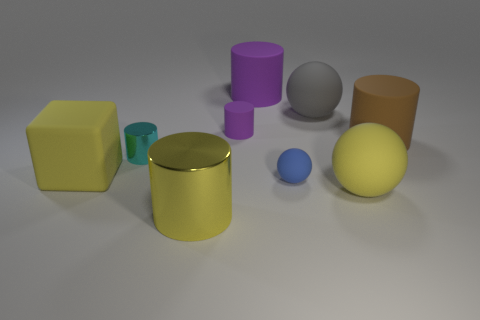What is the material of the sphere that is the same color as the cube?
Keep it short and to the point. Rubber. How many matte things are the same color as the big metal thing?
Offer a terse response. 2. Does the cyan cylinder have the same size as the brown rubber object?
Give a very brief answer. No. How big is the yellow cylinder in front of the tiny blue ball that is to the left of the big brown rubber thing?
Provide a short and direct response. Large. Is the color of the tiny sphere the same as the cylinder in front of the blue rubber object?
Keep it short and to the point. No. Are there any rubber balls of the same size as the brown cylinder?
Offer a terse response. Yes. How big is the rubber cube in front of the big brown matte cylinder?
Your answer should be compact. Large. Are there any big matte objects that are behind the ball that is behind the cyan metallic thing?
Make the answer very short. Yes. What number of other objects are the same shape as the large brown rubber thing?
Ensure brevity in your answer.  4. Do the big purple matte thing and the big brown thing have the same shape?
Make the answer very short. Yes. 